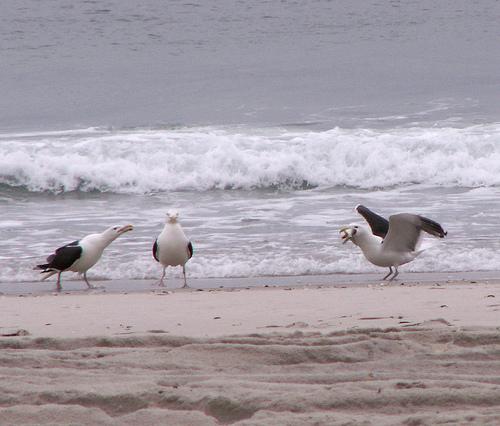How many birds have their wings lifted?
Short answer required. 1. Are the bird's going inside the water?
Concise answer only. No. Are the birds flying?
Be succinct. No. Do you see a seal?
Be succinct. No. Is the bird eating anything?
Answer briefly. Yes. How many bird legs are visible?
Answer briefly. 6. 